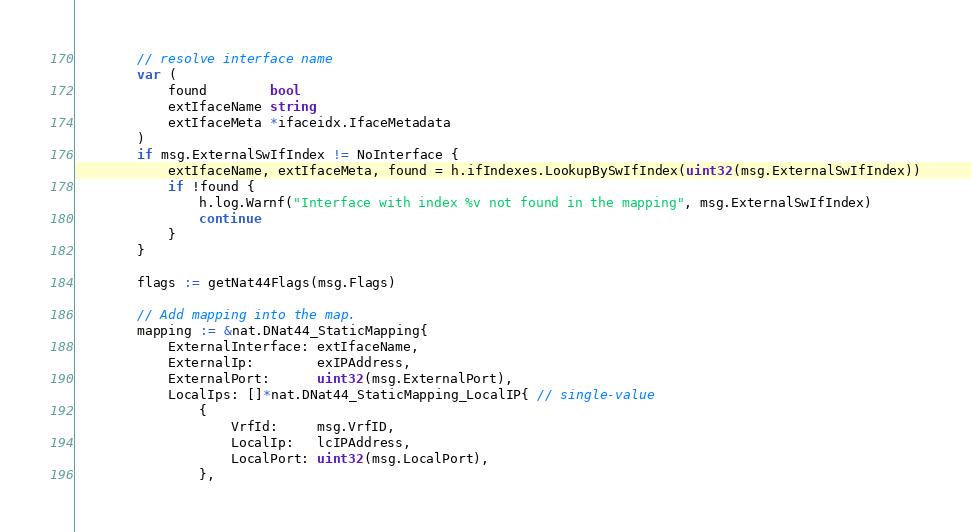<code> <loc_0><loc_0><loc_500><loc_500><_Go_>		// resolve interface name
		var (
			found        bool
			extIfaceName string
			extIfaceMeta *ifaceidx.IfaceMetadata
		)
		if msg.ExternalSwIfIndex != NoInterface {
			extIfaceName, extIfaceMeta, found = h.ifIndexes.LookupBySwIfIndex(uint32(msg.ExternalSwIfIndex))
			if !found {
				h.log.Warnf("Interface with index %v not found in the mapping", msg.ExternalSwIfIndex)
				continue
			}
		}

		flags := getNat44Flags(msg.Flags)

		// Add mapping into the map.
		mapping := &nat.DNat44_StaticMapping{
			ExternalInterface: extIfaceName,
			ExternalIp:        exIPAddress,
			ExternalPort:      uint32(msg.ExternalPort),
			LocalIps: []*nat.DNat44_StaticMapping_LocalIP{ // single-value
				{
					VrfId:     msg.VrfID,
					LocalIp:   lcIPAddress,
					LocalPort: uint32(msg.LocalPort),
				},</code> 